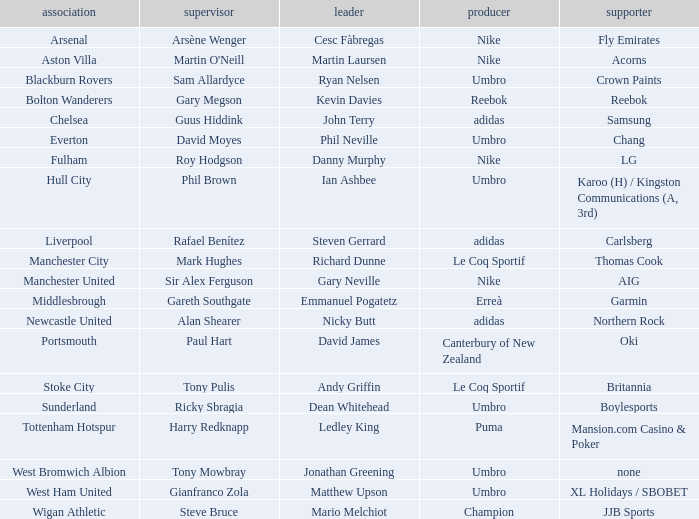What Premier League Manager has an Adidas sponsor and a Newcastle United club? Alan Shearer. 